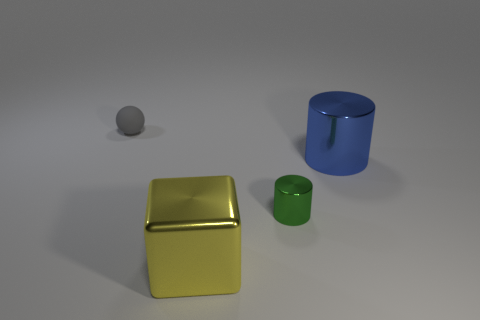What is the shape of the blue thing that is the same material as the small cylinder?
Offer a terse response. Cylinder. There is a big thing that is in front of the object that is to the right of the tiny thing that is in front of the tiny gray rubber thing; what shape is it?
Your answer should be compact. Cube. Are there more large blue metallic cylinders than large brown matte blocks?
Give a very brief answer. Yes. What material is the other object that is the same shape as the blue object?
Offer a terse response. Metal. Is the material of the blue object the same as the ball?
Give a very brief answer. No. Is the number of large yellow metallic things to the right of the small rubber sphere greater than the number of large blue rubber blocks?
Offer a terse response. Yes. What is the small object on the left side of the large shiny object that is to the left of the small thing that is in front of the large blue cylinder made of?
Keep it short and to the point. Rubber. How many things are either gray matte objects or cylinders that are to the right of the tiny cylinder?
Offer a terse response. 2. Is the color of the small object right of the small rubber ball the same as the big metallic block?
Ensure brevity in your answer.  No. Are there more green things that are in front of the large blue shiny cylinder than metallic cylinders that are left of the large yellow metal thing?
Keep it short and to the point. Yes. 